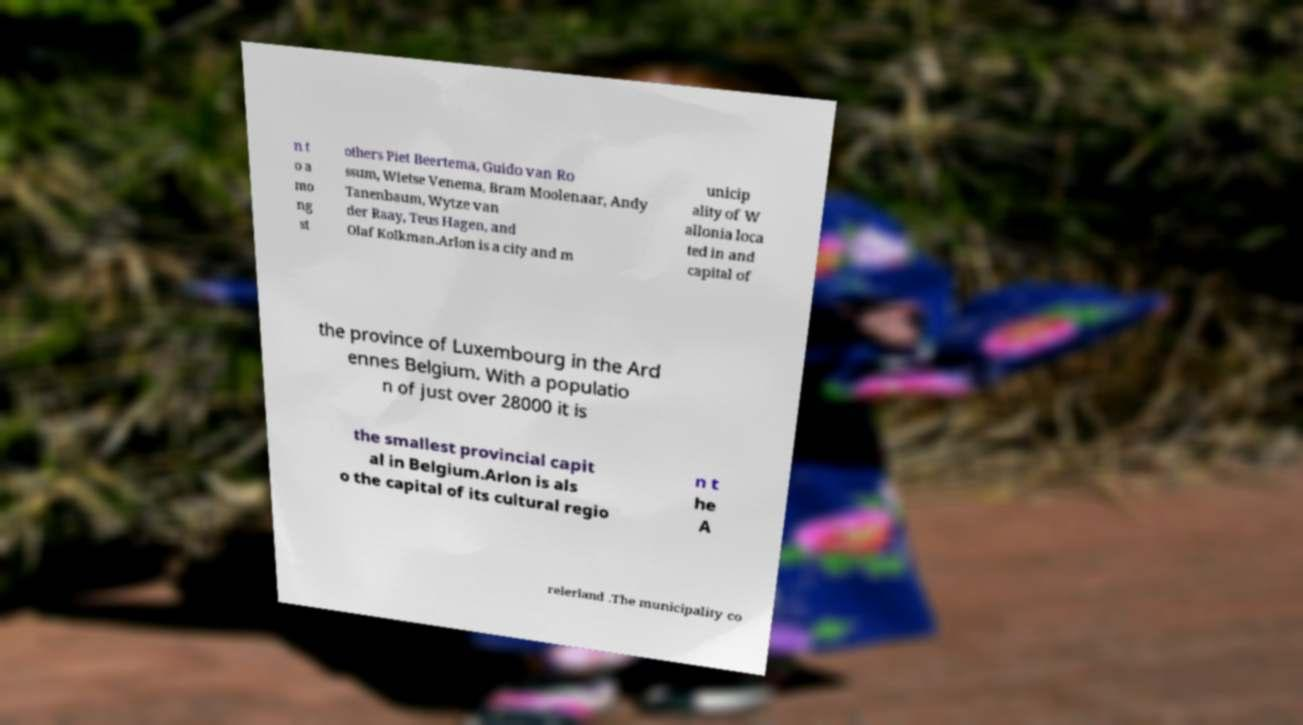Please identify and transcribe the text found in this image. n t o a mo ng st others Piet Beertema, Guido van Ro ssum, Wietse Venema, Bram Moolenaar, Andy Tanenbaum, Wytze van der Raay, Teus Hagen, and Olaf Kolkman.Arlon is a city and m unicip ality of W allonia loca ted in and capital of the province of Luxembourg in the Ard ennes Belgium. With a populatio n of just over 28000 it is the smallest provincial capit al in Belgium.Arlon is als o the capital of its cultural regio n t he A relerland .The municipality co 